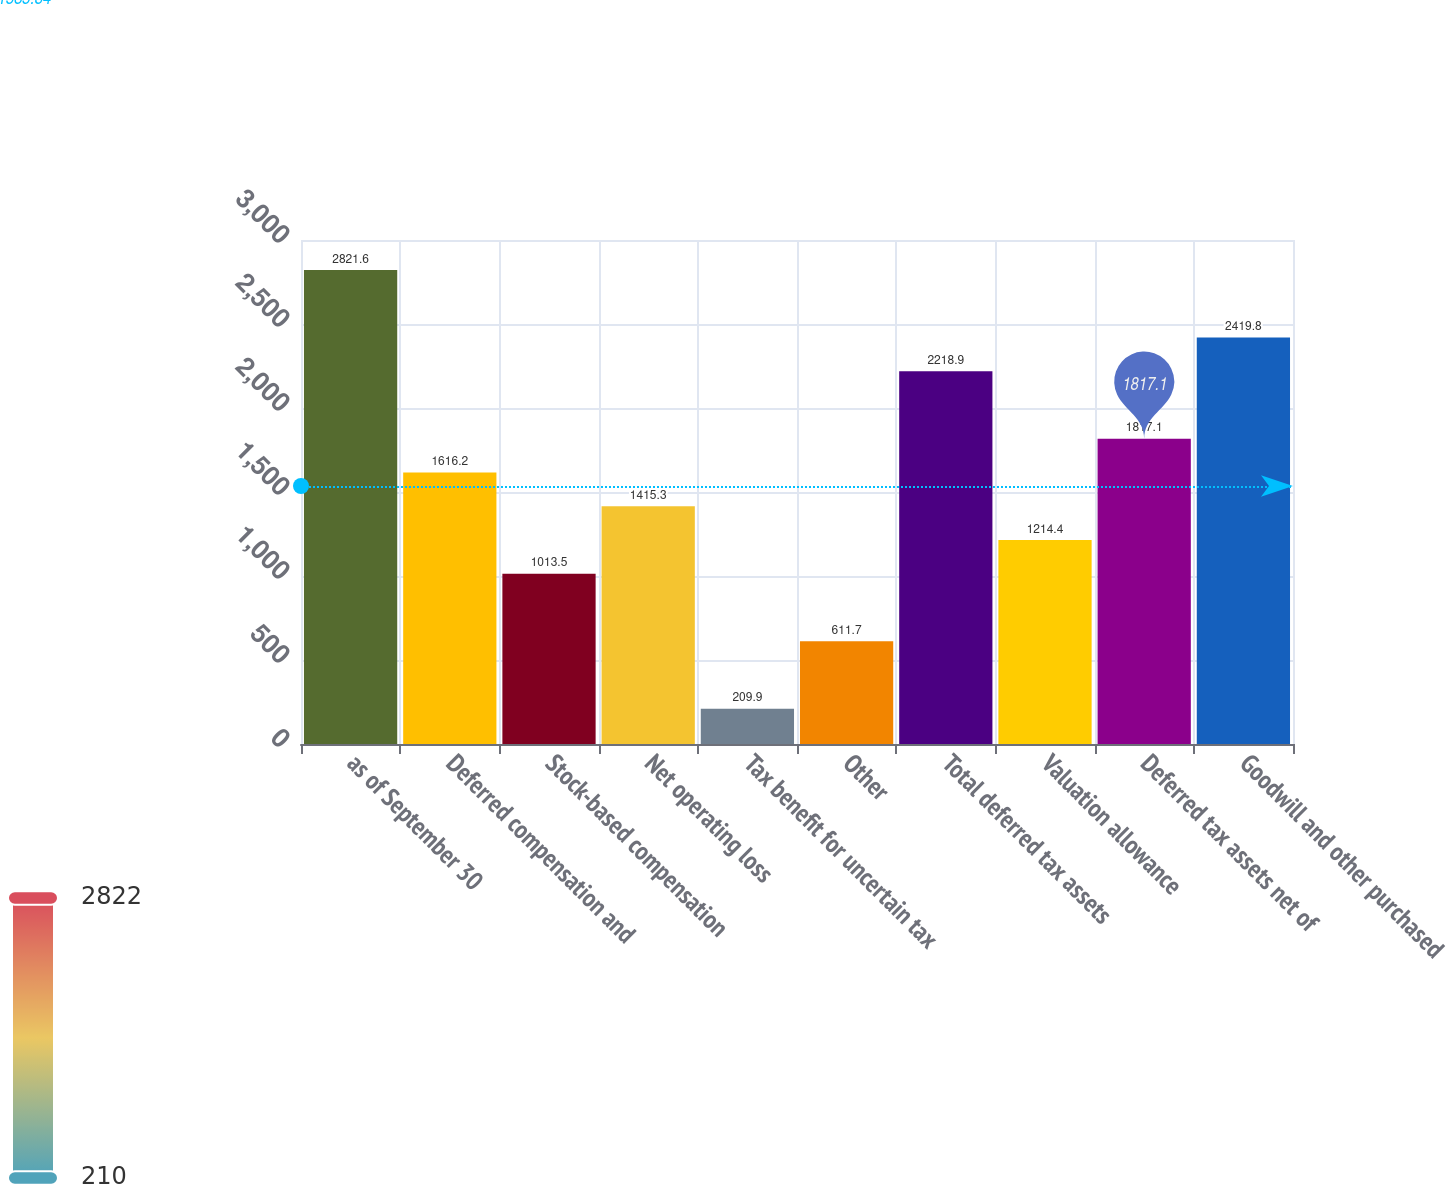<chart> <loc_0><loc_0><loc_500><loc_500><bar_chart><fcel>as of September 30<fcel>Deferred compensation and<fcel>Stock-based compensation<fcel>Net operating loss<fcel>Tax benefit for uncertain tax<fcel>Other<fcel>Total deferred tax assets<fcel>Valuation allowance<fcel>Deferred tax assets net of<fcel>Goodwill and other purchased<nl><fcel>2821.6<fcel>1616.2<fcel>1013.5<fcel>1415.3<fcel>209.9<fcel>611.7<fcel>2218.9<fcel>1214.4<fcel>1817.1<fcel>2419.8<nl></chart> 